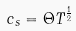Convert formula to latex. <formula><loc_0><loc_0><loc_500><loc_500>c _ { s } = { \Theta } T ^ { \frac { 1 } { 2 } }</formula> 